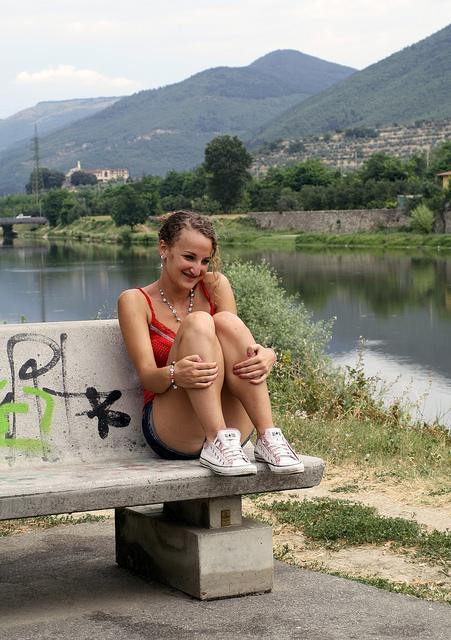How does this person feel about the photographer? Please explain your reasoning. likes alot. The person likes it. 